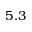Convert formula to latex. <formula><loc_0><loc_0><loc_500><loc_500>5 . 3</formula> 